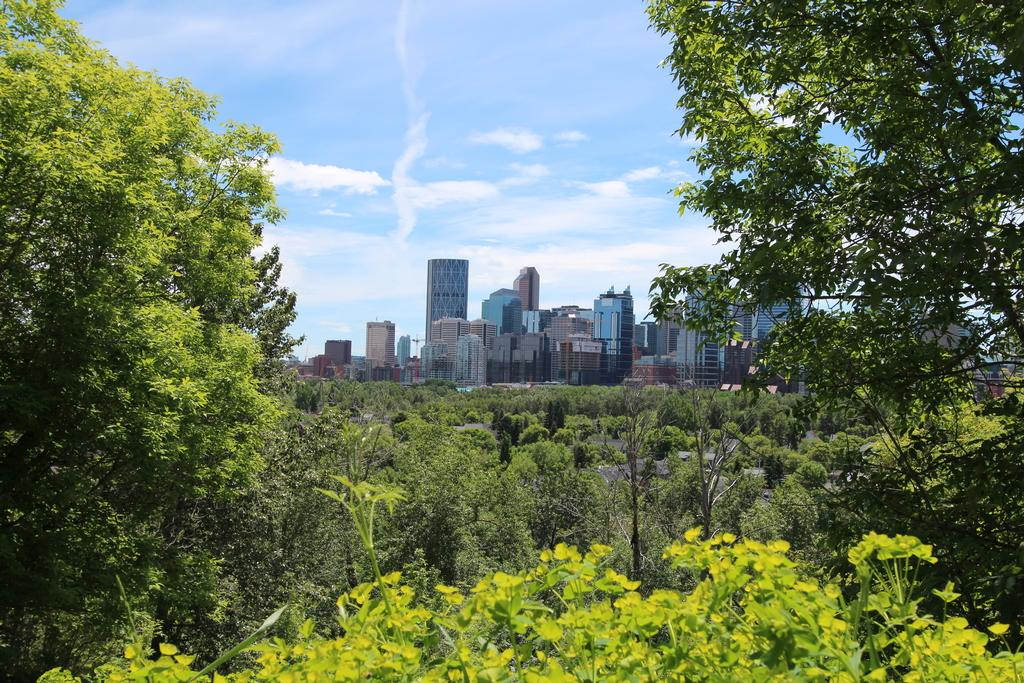What type of natural elements can be seen in the image? There are trees in the image. What type of man-made structures are visible in the image? There are buildings in the image. What is visible in the background of the image? The sky is visible in the background of the image. What can be observed in the sky? Clouds are present in the sky. Where is the beggar located in the image? There is no beggar present in the image. What type of yoke is being used by the trees in the image? There are no yokes present in the image, as trees do not require yokes. 